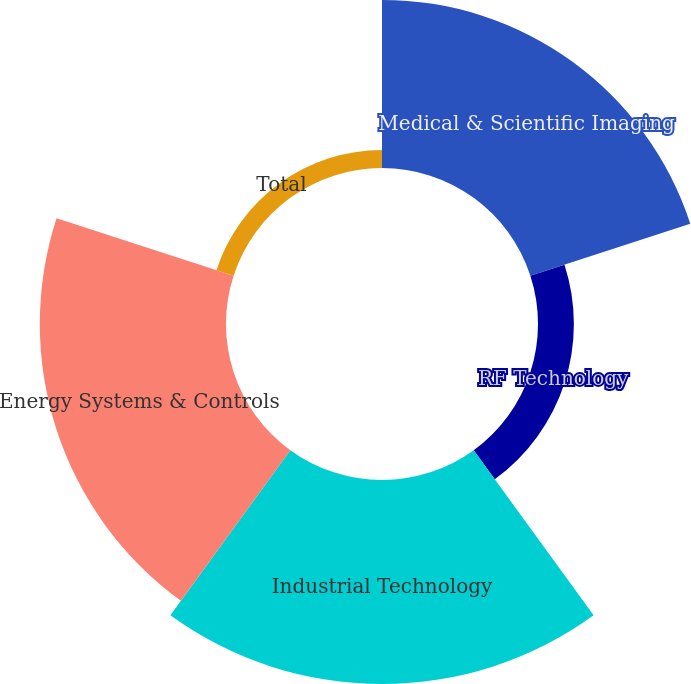<chart> <loc_0><loc_0><loc_500><loc_500><pie_chart><fcel>Medical & Scientific Imaging<fcel>RF Technology<fcel>Industrial Technology<fcel>Energy Systems & Controls<fcel>Total<nl><fcel>27.46%<fcel>5.86%<fcel>33.32%<fcel>30.41%<fcel>2.96%<nl></chart> 